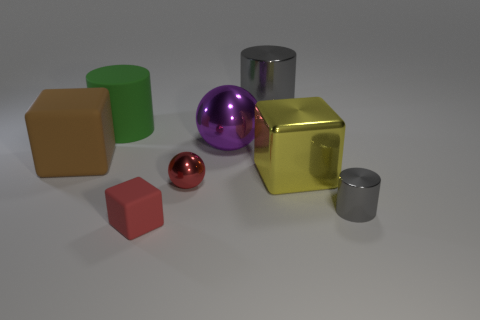The matte block behind the big block that is right of the red metallic sphere on the right side of the large matte cube is what color?
Ensure brevity in your answer.  Brown. Are there more large blocks that are to the right of the large purple shiny object than tiny gray cylinders that are behind the small gray metallic object?
Give a very brief answer. Yes. What number of other things are the same size as the red matte thing?
Provide a short and direct response. 2. There is a shiny object that is the same color as the tiny shiny cylinder; what size is it?
Ensure brevity in your answer.  Large. The big cylinder that is left of the matte cube that is in front of the brown rubber thing is made of what material?
Ensure brevity in your answer.  Rubber. Are there any green objects in front of the big yellow cube?
Keep it short and to the point. No. Are there more tiny metallic spheres that are behind the purple shiny ball than small red shiny cubes?
Provide a succinct answer. No. Is there another big cylinder of the same color as the matte cylinder?
Your response must be concise. No. What color is the other cylinder that is the same size as the green cylinder?
Offer a terse response. Gray. Are there any metallic cylinders that are to the left of the large cylinder on the left side of the tiny cube?
Offer a terse response. No. 